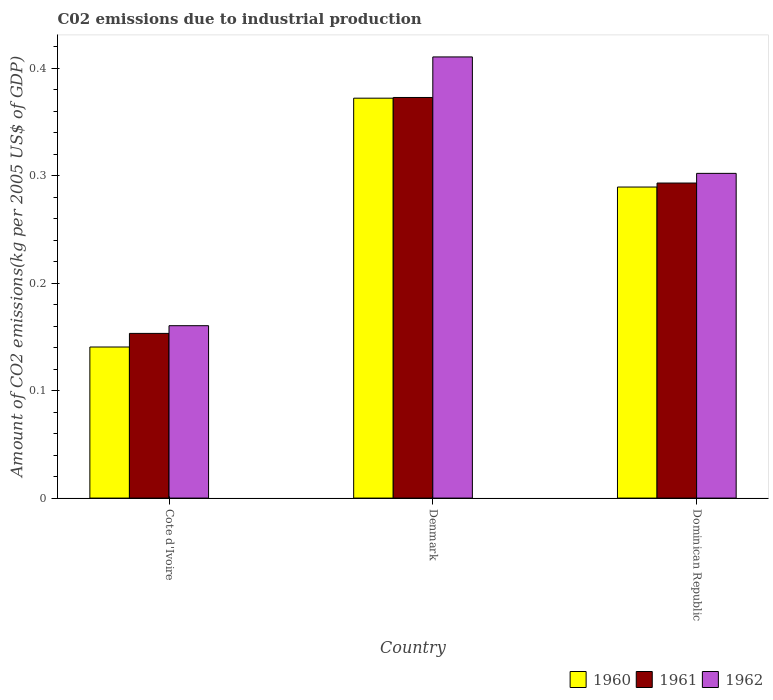How many groups of bars are there?
Ensure brevity in your answer.  3. Are the number of bars per tick equal to the number of legend labels?
Your response must be concise. Yes. Are the number of bars on each tick of the X-axis equal?
Your response must be concise. Yes. What is the label of the 3rd group of bars from the left?
Offer a terse response. Dominican Republic. What is the amount of CO2 emitted due to industrial production in 1960 in Dominican Republic?
Provide a short and direct response. 0.29. Across all countries, what is the maximum amount of CO2 emitted due to industrial production in 1960?
Your response must be concise. 0.37. Across all countries, what is the minimum amount of CO2 emitted due to industrial production in 1962?
Keep it short and to the point. 0.16. In which country was the amount of CO2 emitted due to industrial production in 1960 minimum?
Your answer should be compact. Cote d'Ivoire. What is the total amount of CO2 emitted due to industrial production in 1962 in the graph?
Make the answer very short. 0.87. What is the difference between the amount of CO2 emitted due to industrial production in 1962 in Denmark and that in Dominican Republic?
Your answer should be compact. 0.11. What is the difference between the amount of CO2 emitted due to industrial production in 1960 in Dominican Republic and the amount of CO2 emitted due to industrial production in 1961 in Denmark?
Your answer should be very brief. -0.08. What is the average amount of CO2 emitted due to industrial production in 1961 per country?
Keep it short and to the point. 0.27. What is the difference between the amount of CO2 emitted due to industrial production of/in 1960 and amount of CO2 emitted due to industrial production of/in 1962 in Cote d'Ivoire?
Your response must be concise. -0.02. What is the ratio of the amount of CO2 emitted due to industrial production in 1960 in Denmark to that in Dominican Republic?
Ensure brevity in your answer.  1.29. Is the amount of CO2 emitted due to industrial production in 1961 in Cote d'Ivoire less than that in Denmark?
Ensure brevity in your answer.  Yes. What is the difference between the highest and the second highest amount of CO2 emitted due to industrial production in 1961?
Offer a very short reply. 0.22. What is the difference between the highest and the lowest amount of CO2 emitted due to industrial production in 1961?
Keep it short and to the point. 0.22. In how many countries, is the amount of CO2 emitted due to industrial production in 1961 greater than the average amount of CO2 emitted due to industrial production in 1961 taken over all countries?
Offer a very short reply. 2. What does the 3rd bar from the left in Denmark represents?
Provide a short and direct response. 1962. What does the 2nd bar from the right in Denmark represents?
Offer a terse response. 1961. Is it the case that in every country, the sum of the amount of CO2 emitted due to industrial production in 1960 and amount of CO2 emitted due to industrial production in 1962 is greater than the amount of CO2 emitted due to industrial production in 1961?
Keep it short and to the point. Yes. How many bars are there?
Make the answer very short. 9. Are all the bars in the graph horizontal?
Your answer should be very brief. No. How many countries are there in the graph?
Provide a short and direct response. 3. What is the difference between two consecutive major ticks on the Y-axis?
Give a very brief answer. 0.1. Are the values on the major ticks of Y-axis written in scientific E-notation?
Make the answer very short. No. Where does the legend appear in the graph?
Make the answer very short. Bottom right. How many legend labels are there?
Ensure brevity in your answer.  3. How are the legend labels stacked?
Keep it short and to the point. Horizontal. What is the title of the graph?
Your answer should be very brief. C02 emissions due to industrial production. Does "1960" appear as one of the legend labels in the graph?
Your answer should be compact. Yes. What is the label or title of the X-axis?
Your answer should be very brief. Country. What is the label or title of the Y-axis?
Give a very brief answer. Amount of CO2 emissions(kg per 2005 US$ of GDP). What is the Amount of CO2 emissions(kg per 2005 US$ of GDP) in 1960 in Cote d'Ivoire?
Offer a very short reply. 0.14. What is the Amount of CO2 emissions(kg per 2005 US$ of GDP) in 1961 in Cote d'Ivoire?
Offer a very short reply. 0.15. What is the Amount of CO2 emissions(kg per 2005 US$ of GDP) of 1962 in Cote d'Ivoire?
Your answer should be very brief. 0.16. What is the Amount of CO2 emissions(kg per 2005 US$ of GDP) in 1960 in Denmark?
Your answer should be very brief. 0.37. What is the Amount of CO2 emissions(kg per 2005 US$ of GDP) in 1961 in Denmark?
Your answer should be compact. 0.37. What is the Amount of CO2 emissions(kg per 2005 US$ of GDP) of 1962 in Denmark?
Offer a terse response. 0.41. What is the Amount of CO2 emissions(kg per 2005 US$ of GDP) of 1960 in Dominican Republic?
Your answer should be very brief. 0.29. What is the Amount of CO2 emissions(kg per 2005 US$ of GDP) in 1961 in Dominican Republic?
Your answer should be very brief. 0.29. What is the Amount of CO2 emissions(kg per 2005 US$ of GDP) of 1962 in Dominican Republic?
Your answer should be compact. 0.3. Across all countries, what is the maximum Amount of CO2 emissions(kg per 2005 US$ of GDP) of 1960?
Provide a short and direct response. 0.37. Across all countries, what is the maximum Amount of CO2 emissions(kg per 2005 US$ of GDP) in 1961?
Your response must be concise. 0.37. Across all countries, what is the maximum Amount of CO2 emissions(kg per 2005 US$ of GDP) in 1962?
Your answer should be compact. 0.41. Across all countries, what is the minimum Amount of CO2 emissions(kg per 2005 US$ of GDP) in 1960?
Offer a very short reply. 0.14. Across all countries, what is the minimum Amount of CO2 emissions(kg per 2005 US$ of GDP) in 1961?
Provide a short and direct response. 0.15. Across all countries, what is the minimum Amount of CO2 emissions(kg per 2005 US$ of GDP) in 1962?
Make the answer very short. 0.16. What is the total Amount of CO2 emissions(kg per 2005 US$ of GDP) in 1960 in the graph?
Your answer should be compact. 0.8. What is the total Amount of CO2 emissions(kg per 2005 US$ of GDP) of 1961 in the graph?
Provide a succinct answer. 0.82. What is the total Amount of CO2 emissions(kg per 2005 US$ of GDP) in 1962 in the graph?
Your answer should be very brief. 0.87. What is the difference between the Amount of CO2 emissions(kg per 2005 US$ of GDP) of 1960 in Cote d'Ivoire and that in Denmark?
Make the answer very short. -0.23. What is the difference between the Amount of CO2 emissions(kg per 2005 US$ of GDP) of 1961 in Cote d'Ivoire and that in Denmark?
Provide a short and direct response. -0.22. What is the difference between the Amount of CO2 emissions(kg per 2005 US$ of GDP) of 1962 in Cote d'Ivoire and that in Denmark?
Ensure brevity in your answer.  -0.25. What is the difference between the Amount of CO2 emissions(kg per 2005 US$ of GDP) of 1960 in Cote d'Ivoire and that in Dominican Republic?
Make the answer very short. -0.15. What is the difference between the Amount of CO2 emissions(kg per 2005 US$ of GDP) of 1961 in Cote d'Ivoire and that in Dominican Republic?
Your answer should be very brief. -0.14. What is the difference between the Amount of CO2 emissions(kg per 2005 US$ of GDP) of 1962 in Cote d'Ivoire and that in Dominican Republic?
Your answer should be very brief. -0.14. What is the difference between the Amount of CO2 emissions(kg per 2005 US$ of GDP) in 1960 in Denmark and that in Dominican Republic?
Offer a very short reply. 0.08. What is the difference between the Amount of CO2 emissions(kg per 2005 US$ of GDP) of 1961 in Denmark and that in Dominican Republic?
Your answer should be compact. 0.08. What is the difference between the Amount of CO2 emissions(kg per 2005 US$ of GDP) in 1962 in Denmark and that in Dominican Republic?
Your answer should be very brief. 0.11. What is the difference between the Amount of CO2 emissions(kg per 2005 US$ of GDP) in 1960 in Cote d'Ivoire and the Amount of CO2 emissions(kg per 2005 US$ of GDP) in 1961 in Denmark?
Offer a very short reply. -0.23. What is the difference between the Amount of CO2 emissions(kg per 2005 US$ of GDP) in 1960 in Cote d'Ivoire and the Amount of CO2 emissions(kg per 2005 US$ of GDP) in 1962 in Denmark?
Ensure brevity in your answer.  -0.27. What is the difference between the Amount of CO2 emissions(kg per 2005 US$ of GDP) in 1961 in Cote d'Ivoire and the Amount of CO2 emissions(kg per 2005 US$ of GDP) in 1962 in Denmark?
Make the answer very short. -0.26. What is the difference between the Amount of CO2 emissions(kg per 2005 US$ of GDP) of 1960 in Cote d'Ivoire and the Amount of CO2 emissions(kg per 2005 US$ of GDP) of 1961 in Dominican Republic?
Your response must be concise. -0.15. What is the difference between the Amount of CO2 emissions(kg per 2005 US$ of GDP) of 1960 in Cote d'Ivoire and the Amount of CO2 emissions(kg per 2005 US$ of GDP) of 1962 in Dominican Republic?
Keep it short and to the point. -0.16. What is the difference between the Amount of CO2 emissions(kg per 2005 US$ of GDP) in 1961 in Cote d'Ivoire and the Amount of CO2 emissions(kg per 2005 US$ of GDP) in 1962 in Dominican Republic?
Provide a succinct answer. -0.15. What is the difference between the Amount of CO2 emissions(kg per 2005 US$ of GDP) of 1960 in Denmark and the Amount of CO2 emissions(kg per 2005 US$ of GDP) of 1961 in Dominican Republic?
Your answer should be compact. 0.08. What is the difference between the Amount of CO2 emissions(kg per 2005 US$ of GDP) of 1960 in Denmark and the Amount of CO2 emissions(kg per 2005 US$ of GDP) of 1962 in Dominican Republic?
Provide a succinct answer. 0.07. What is the difference between the Amount of CO2 emissions(kg per 2005 US$ of GDP) of 1961 in Denmark and the Amount of CO2 emissions(kg per 2005 US$ of GDP) of 1962 in Dominican Republic?
Provide a short and direct response. 0.07. What is the average Amount of CO2 emissions(kg per 2005 US$ of GDP) in 1960 per country?
Offer a terse response. 0.27. What is the average Amount of CO2 emissions(kg per 2005 US$ of GDP) in 1961 per country?
Ensure brevity in your answer.  0.27. What is the average Amount of CO2 emissions(kg per 2005 US$ of GDP) of 1962 per country?
Provide a short and direct response. 0.29. What is the difference between the Amount of CO2 emissions(kg per 2005 US$ of GDP) of 1960 and Amount of CO2 emissions(kg per 2005 US$ of GDP) of 1961 in Cote d'Ivoire?
Keep it short and to the point. -0.01. What is the difference between the Amount of CO2 emissions(kg per 2005 US$ of GDP) in 1960 and Amount of CO2 emissions(kg per 2005 US$ of GDP) in 1962 in Cote d'Ivoire?
Keep it short and to the point. -0.02. What is the difference between the Amount of CO2 emissions(kg per 2005 US$ of GDP) in 1961 and Amount of CO2 emissions(kg per 2005 US$ of GDP) in 1962 in Cote d'Ivoire?
Your response must be concise. -0.01. What is the difference between the Amount of CO2 emissions(kg per 2005 US$ of GDP) of 1960 and Amount of CO2 emissions(kg per 2005 US$ of GDP) of 1961 in Denmark?
Ensure brevity in your answer.  -0. What is the difference between the Amount of CO2 emissions(kg per 2005 US$ of GDP) of 1960 and Amount of CO2 emissions(kg per 2005 US$ of GDP) of 1962 in Denmark?
Provide a short and direct response. -0.04. What is the difference between the Amount of CO2 emissions(kg per 2005 US$ of GDP) of 1961 and Amount of CO2 emissions(kg per 2005 US$ of GDP) of 1962 in Denmark?
Keep it short and to the point. -0.04. What is the difference between the Amount of CO2 emissions(kg per 2005 US$ of GDP) in 1960 and Amount of CO2 emissions(kg per 2005 US$ of GDP) in 1961 in Dominican Republic?
Your answer should be very brief. -0. What is the difference between the Amount of CO2 emissions(kg per 2005 US$ of GDP) of 1960 and Amount of CO2 emissions(kg per 2005 US$ of GDP) of 1962 in Dominican Republic?
Provide a succinct answer. -0.01. What is the difference between the Amount of CO2 emissions(kg per 2005 US$ of GDP) of 1961 and Amount of CO2 emissions(kg per 2005 US$ of GDP) of 1962 in Dominican Republic?
Provide a short and direct response. -0.01. What is the ratio of the Amount of CO2 emissions(kg per 2005 US$ of GDP) of 1960 in Cote d'Ivoire to that in Denmark?
Provide a short and direct response. 0.38. What is the ratio of the Amount of CO2 emissions(kg per 2005 US$ of GDP) of 1961 in Cote d'Ivoire to that in Denmark?
Provide a succinct answer. 0.41. What is the ratio of the Amount of CO2 emissions(kg per 2005 US$ of GDP) in 1962 in Cote d'Ivoire to that in Denmark?
Offer a very short reply. 0.39. What is the ratio of the Amount of CO2 emissions(kg per 2005 US$ of GDP) in 1960 in Cote d'Ivoire to that in Dominican Republic?
Your response must be concise. 0.49. What is the ratio of the Amount of CO2 emissions(kg per 2005 US$ of GDP) in 1961 in Cote d'Ivoire to that in Dominican Republic?
Give a very brief answer. 0.52. What is the ratio of the Amount of CO2 emissions(kg per 2005 US$ of GDP) of 1962 in Cote d'Ivoire to that in Dominican Republic?
Give a very brief answer. 0.53. What is the ratio of the Amount of CO2 emissions(kg per 2005 US$ of GDP) of 1961 in Denmark to that in Dominican Republic?
Offer a terse response. 1.27. What is the ratio of the Amount of CO2 emissions(kg per 2005 US$ of GDP) in 1962 in Denmark to that in Dominican Republic?
Provide a succinct answer. 1.36. What is the difference between the highest and the second highest Amount of CO2 emissions(kg per 2005 US$ of GDP) of 1960?
Your answer should be compact. 0.08. What is the difference between the highest and the second highest Amount of CO2 emissions(kg per 2005 US$ of GDP) of 1961?
Keep it short and to the point. 0.08. What is the difference between the highest and the second highest Amount of CO2 emissions(kg per 2005 US$ of GDP) of 1962?
Provide a short and direct response. 0.11. What is the difference between the highest and the lowest Amount of CO2 emissions(kg per 2005 US$ of GDP) of 1960?
Provide a short and direct response. 0.23. What is the difference between the highest and the lowest Amount of CO2 emissions(kg per 2005 US$ of GDP) of 1961?
Offer a very short reply. 0.22. What is the difference between the highest and the lowest Amount of CO2 emissions(kg per 2005 US$ of GDP) in 1962?
Provide a succinct answer. 0.25. 